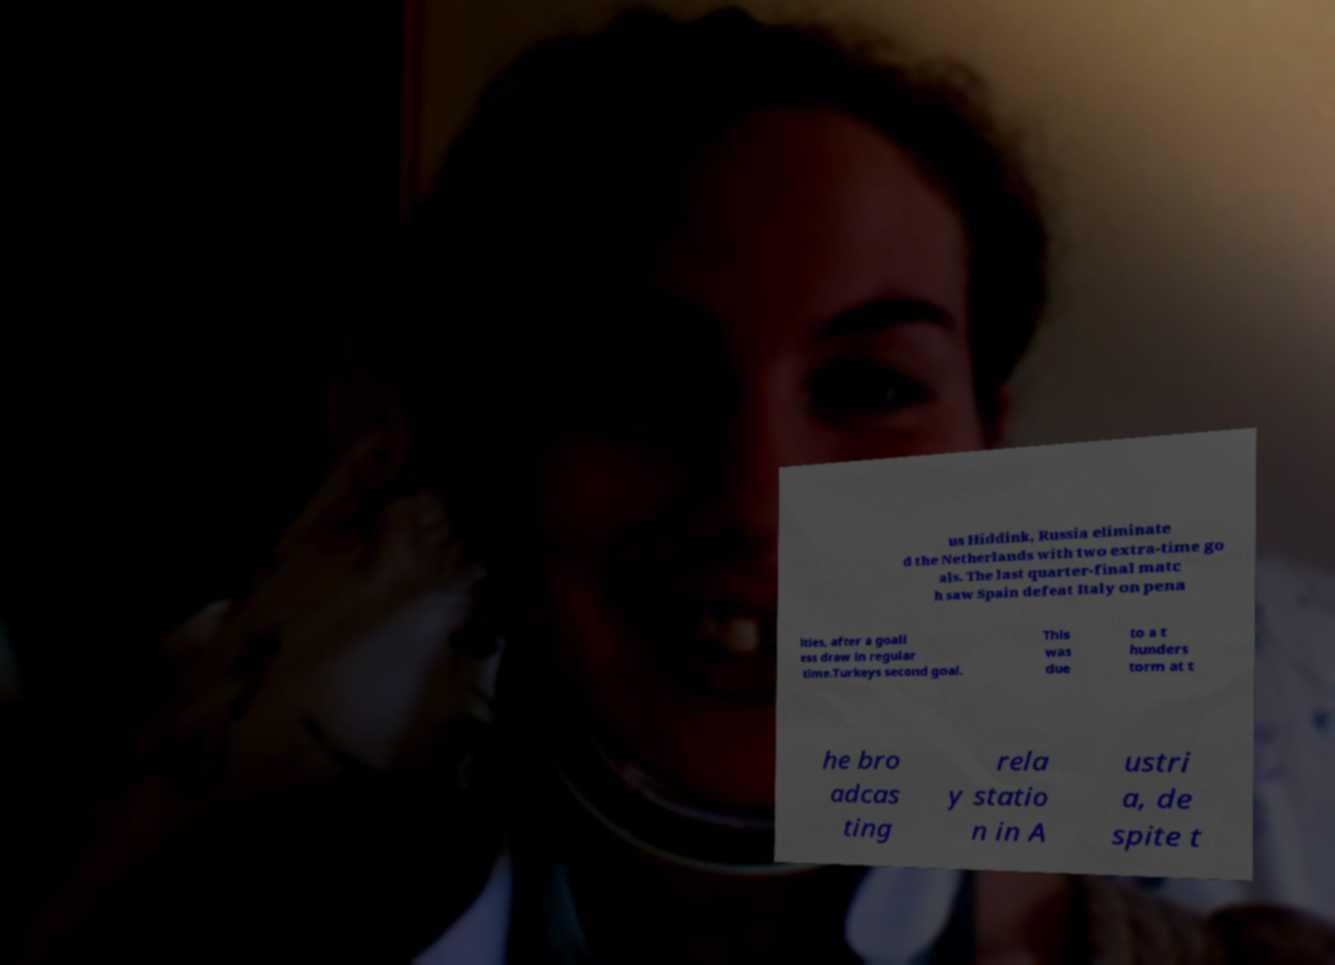Could you assist in decoding the text presented in this image and type it out clearly? us Hiddink, Russia eliminate d the Netherlands with two extra-time go als. The last quarter-final matc h saw Spain defeat Italy on pena lties, after a goall ess draw in regular time.Turkeys second goal. This was due to a t hunders torm at t he bro adcas ting rela y statio n in A ustri a, de spite t 